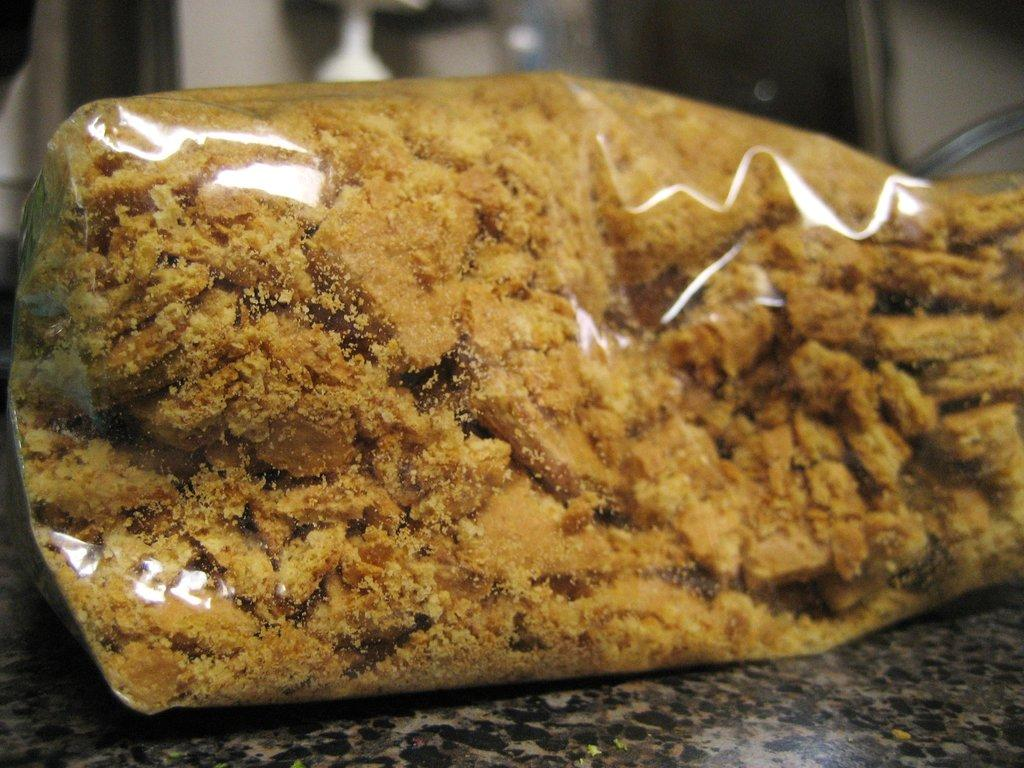What is on the floor in the image? There is a food item on the floor in the image. How many rings are visible on the cactus in the image? There is no cactus or rings present in the image; it only features a food item on the floor. 